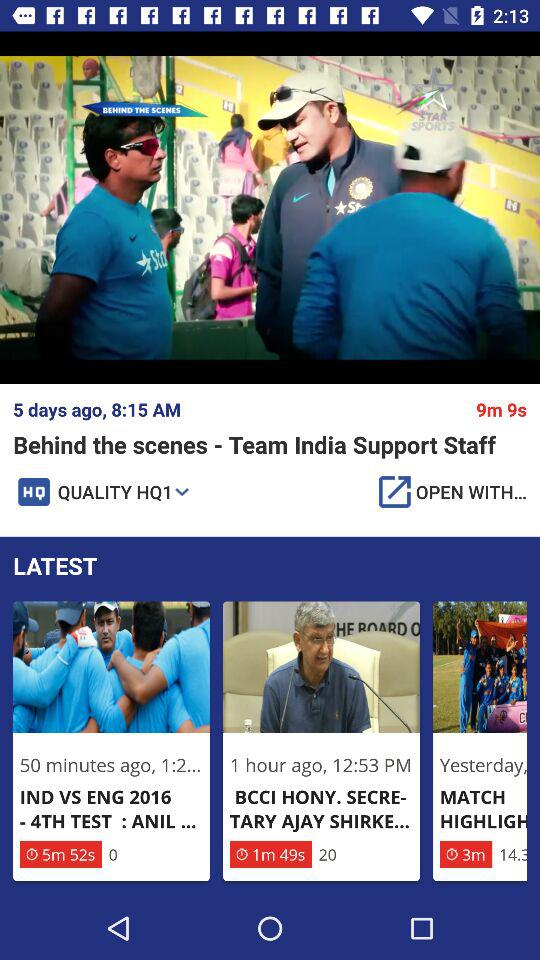What is the video length of the "IND VS ENG 2016 - 4TH TEST"? The video length is 5 minutes and 52 seconds. 